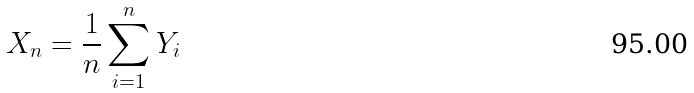<formula> <loc_0><loc_0><loc_500><loc_500>X _ { n } = \frac { 1 } { n } \sum _ { i = 1 } ^ { n } Y _ { i }</formula> 